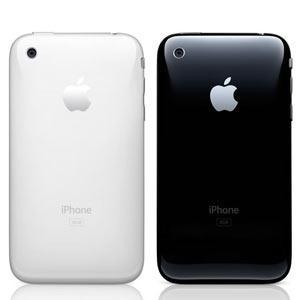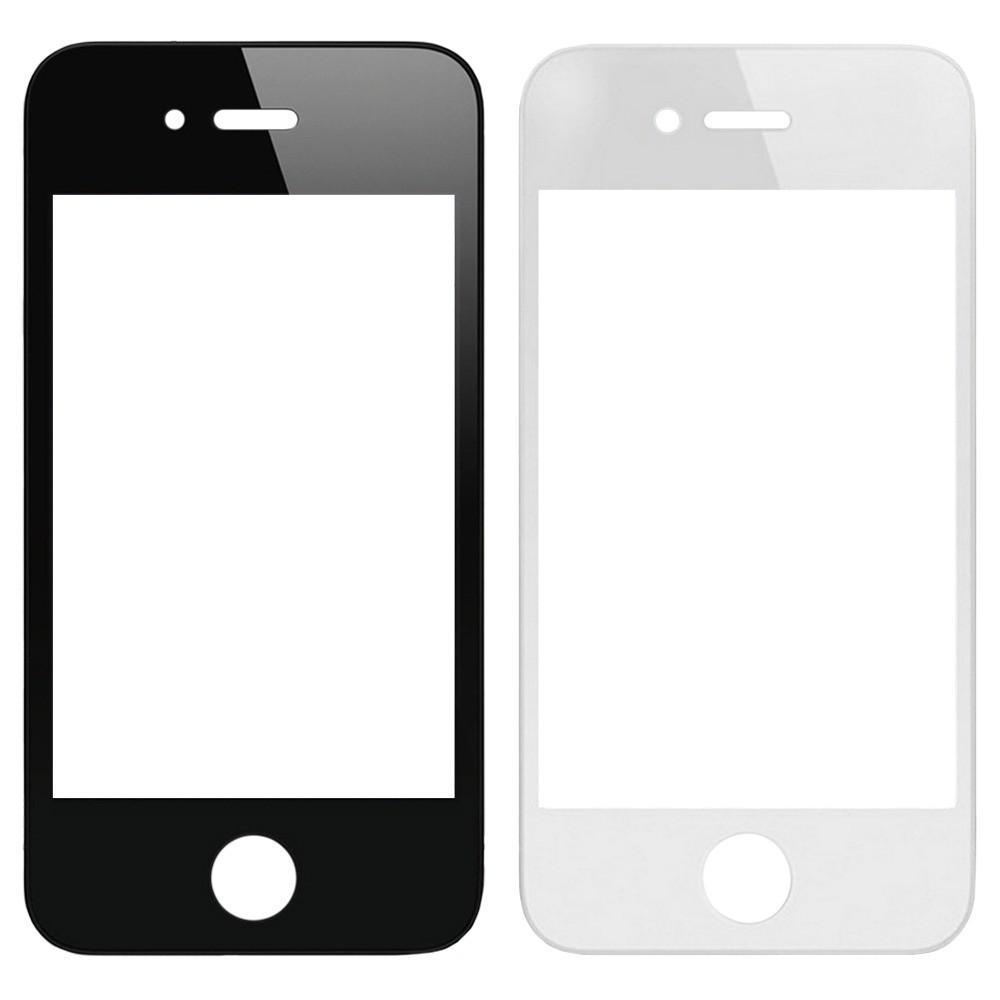The first image is the image on the left, the second image is the image on the right. For the images shown, is this caption "At least one image includes a side-view of a phone to the right of two head-on displayed devices." true? Answer yes or no. No. The first image is the image on the left, the second image is the image on the right. Assess this claim about the two images: "There is a side profile of at least one phone.". Correct or not? Answer yes or no. No. 